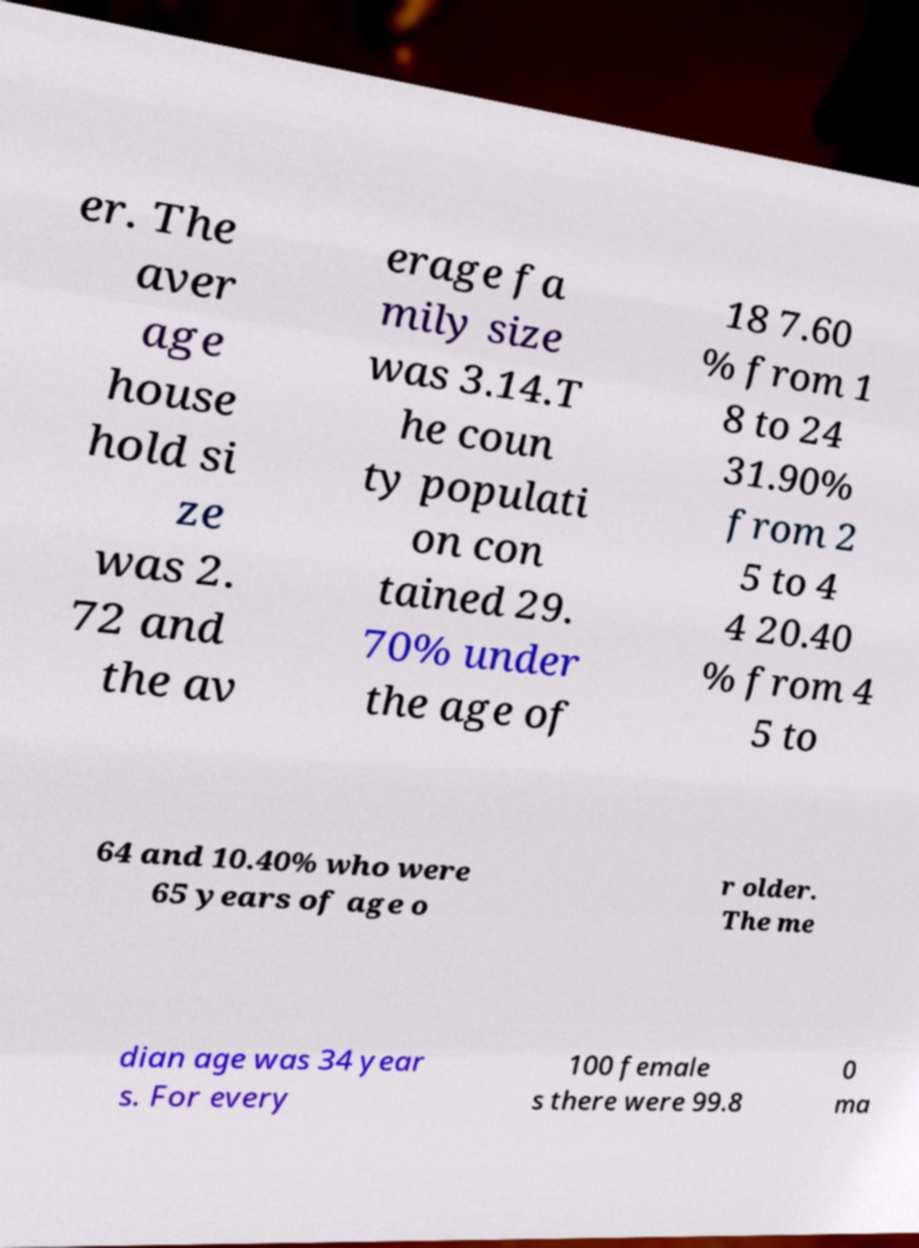Please identify and transcribe the text found in this image. er. The aver age house hold si ze was 2. 72 and the av erage fa mily size was 3.14.T he coun ty populati on con tained 29. 70% under the age of 18 7.60 % from 1 8 to 24 31.90% from 2 5 to 4 4 20.40 % from 4 5 to 64 and 10.40% who were 65 years of age o r older. The me dian age was 34 year s. For every 100 female s there were 99.8 0 ma 